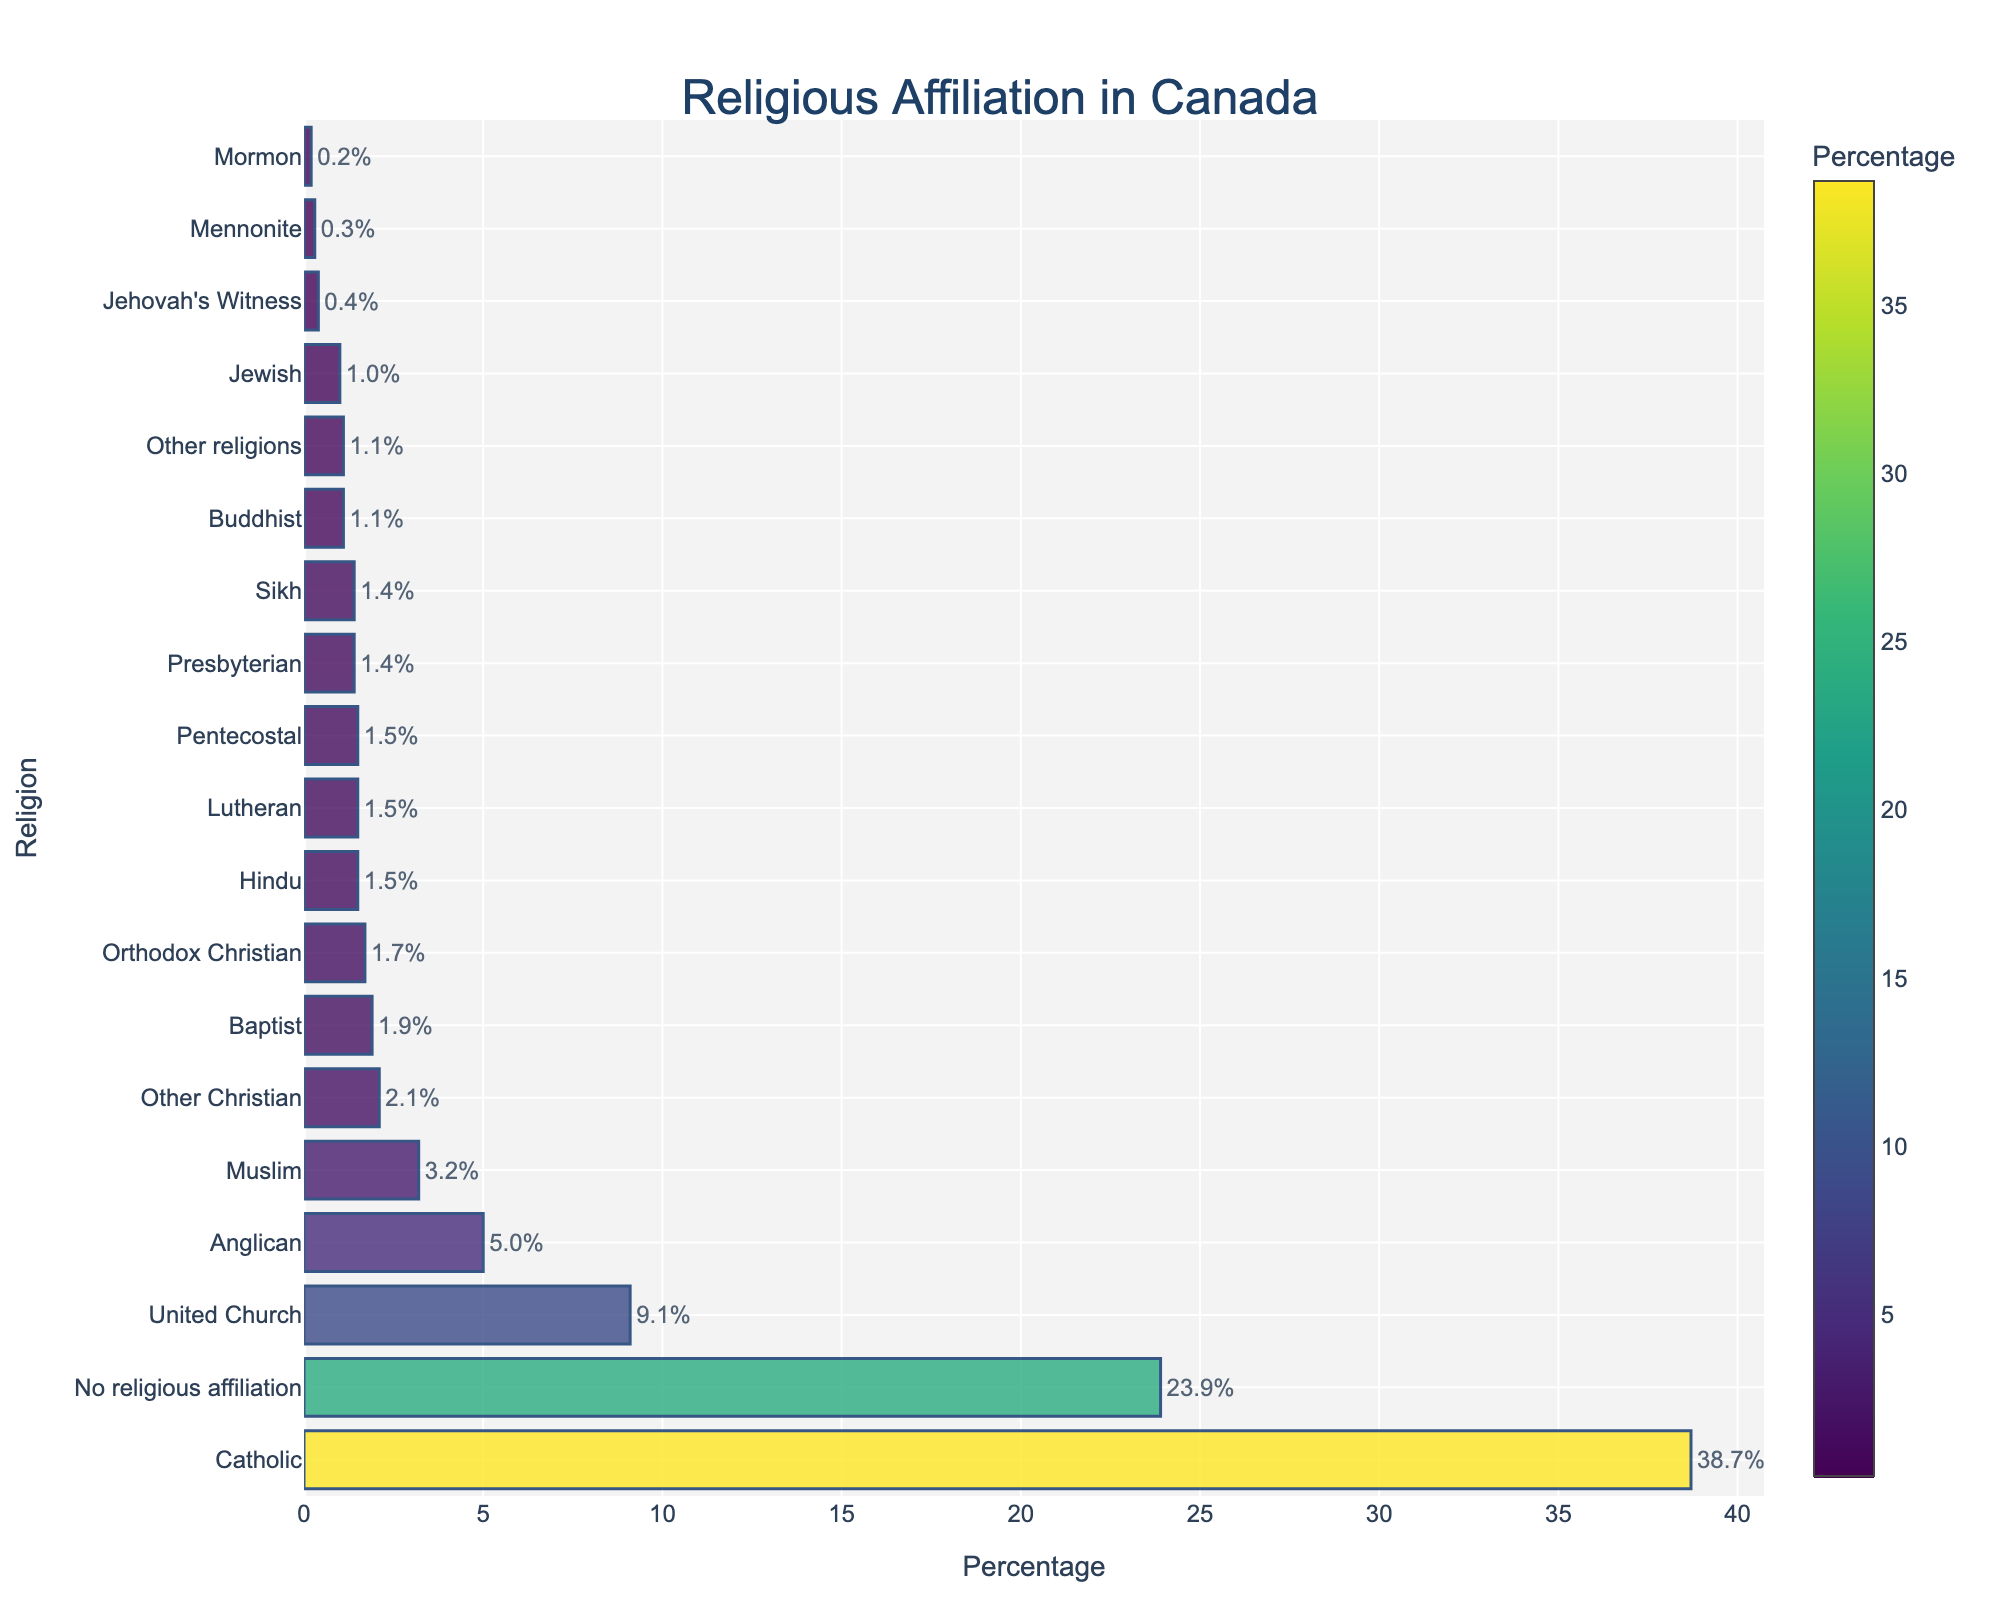Which religious group has the highest percentage? Looking at the horizontal bars and their lengths, the bar for the "Catholic" group is the longest and stands out at the top, indicating it has the highest percentage.
Answer: Catholic (38.7%) What is the percentage difference between "No religious affiliation" and "Catholic"? The "Catholic" group has a percentage of 38.7%, while "No religious affiliation" has 23.9%. Subtracting 23.9 from 38.7 gives the difference.
Answer: 14.8% Which groups have a percentage lower than 2%? Observing the bars, groups such as Baptist, Lutheran, Orthodox Christian, Pentecostal, Presbyterian, Sikh, Hindu, Jewish, Buddhist, Jehovah's Witness, Mennonite, Mormon, and Other religions all have percentages below 2%.
Answer: Baptist, Lutheran, Orthodox Christian, Pentecostal, Presbyterian, Sikh, Hindu, Jewish, Buddhist, Jehovah's Witness, Mennonite, Mormon, Other religions How much higher is the percentage of "Muslim" compared to "Jewish"? The bar for "Muslim" is 3.2% and for "Jewish" is 1.0%. Subtracting 1.0 from 3.2 gives the difference.
Answer: 2.2% What is the total percentage for Christian denominations combined (excluding "No religious affiliation")? Adding the percentages of all Christian groups (Catholic 38.7, United Church 9.1, Anglican 5.0, Baptist 1.9, Lutheran 1.5, Orthodox Christian 1.7, Pentecostal 1.5, Presbyterian 1.4, Mennonite 0.3, Mormon 0.2, Other Christian 2.1) results in the total.
Answer: 63.4% Which group has the smallest percentage? The bar for the "Mormon" group is the shortest, indicating it has the smallest percentage.
Answer: Mormon (0.2%) Is the percentage of "Anglican" higher than that of "United Church"? Comparing the lengths of the bars, the "United Church" bar is longer at 9.1%, whereas "Anglican" is shorter at 5.0%.
Answer: No Are there more people affiliated with "Buddhist" or "Hindu"? By comparing the lengths of the bars, "Hindu" has a longer bar at 1.5% compared to "Buddhist" at 1.1%.
Answer: Hindu What is the combined percentage of "Sikh" and "Jewish"? Adding the percentages of "Sikh" (1.4%) and "Jewish" (1.0%) gives the combined value.
Answer: 2.4% Which group is immediately above "Presbyterian" in percentage terms? Observing the sorted list, "Pentecostal" with 1.5% is just above "Presbyterian" which has 1.4%.
Answer: Pentecostal 